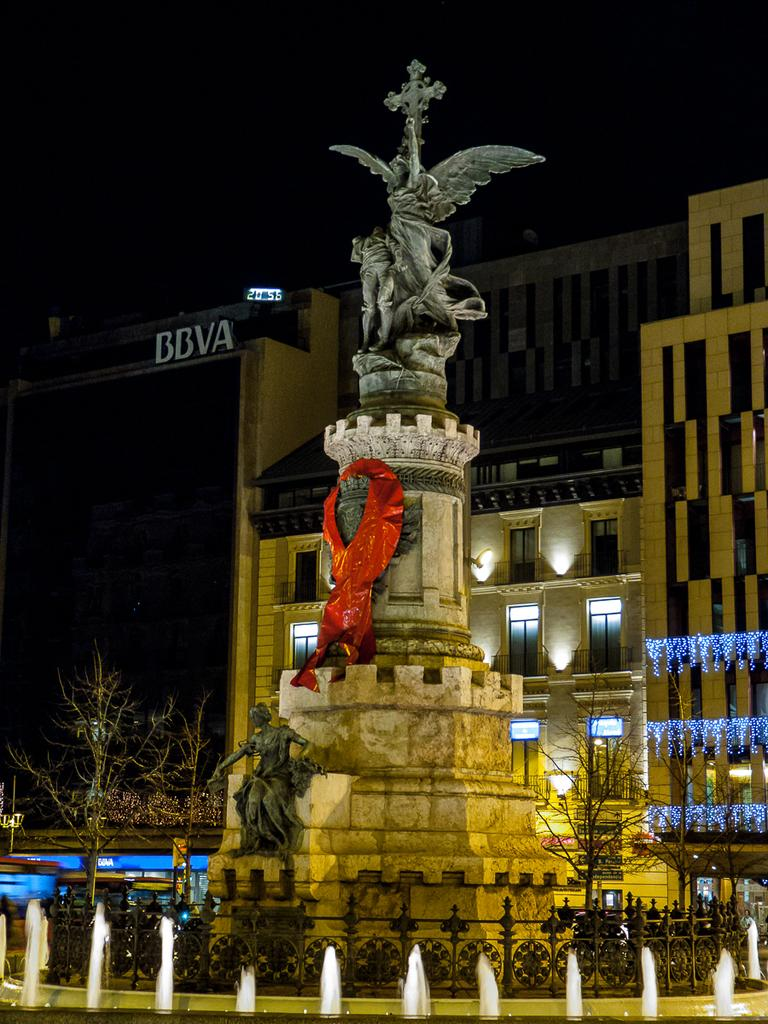What type of objects can be seen in the image? There are statues in the image. What other features are present in the image? There is a fountain in the image. What can be seen in the background of the image? There is a building, trees, lights, and the sky visible in the background of the image. What type of suit is the rock wearing in the image? There is no rock or suit present in the image. Can you describe the teeth of the statues in the image? The statues in the image do not have teeth, as they are inanimate objects. 